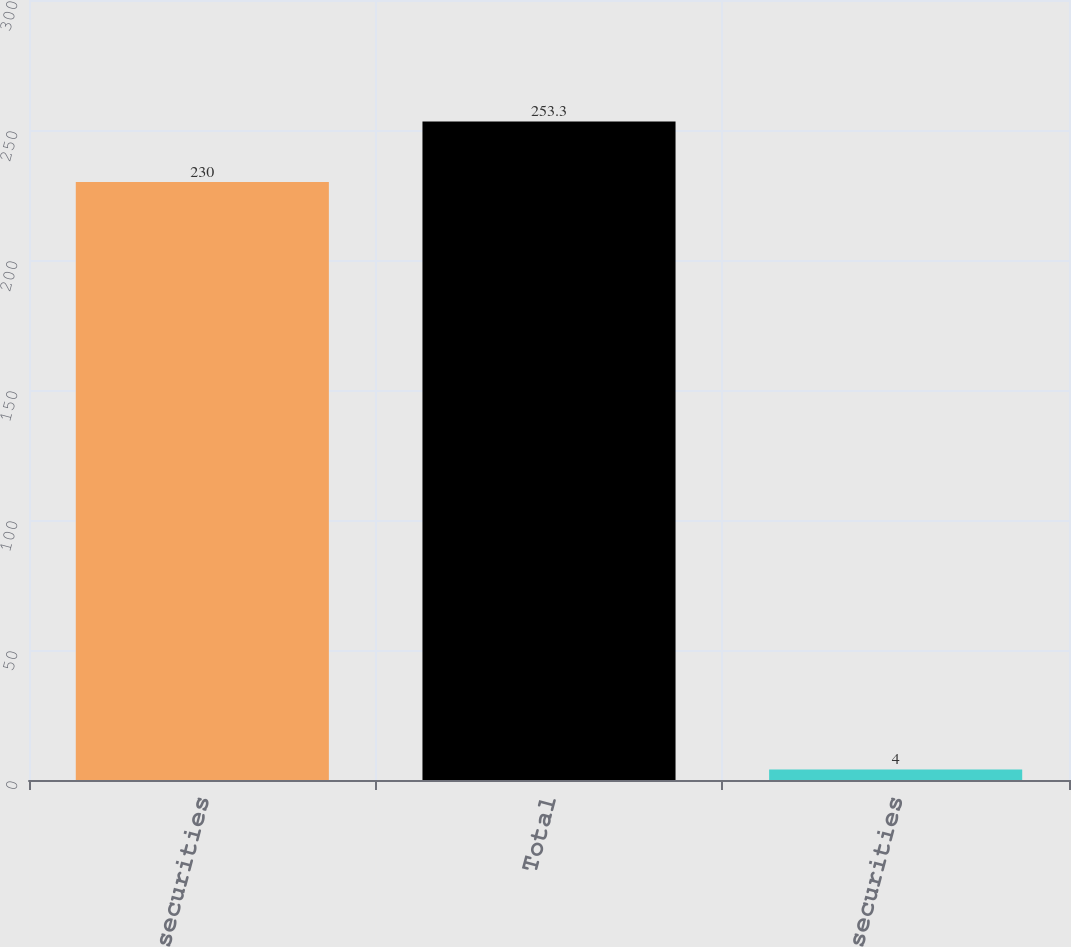Convert chart to OTSL. <chart><loc_0><loc_0><loc_500><loc_500><bar_chart><fcel>Equity securities<fcel>Total<fcel>Debt securities<nl><fcel>230<fcel>253.3<fcel>4<nl></chart> 